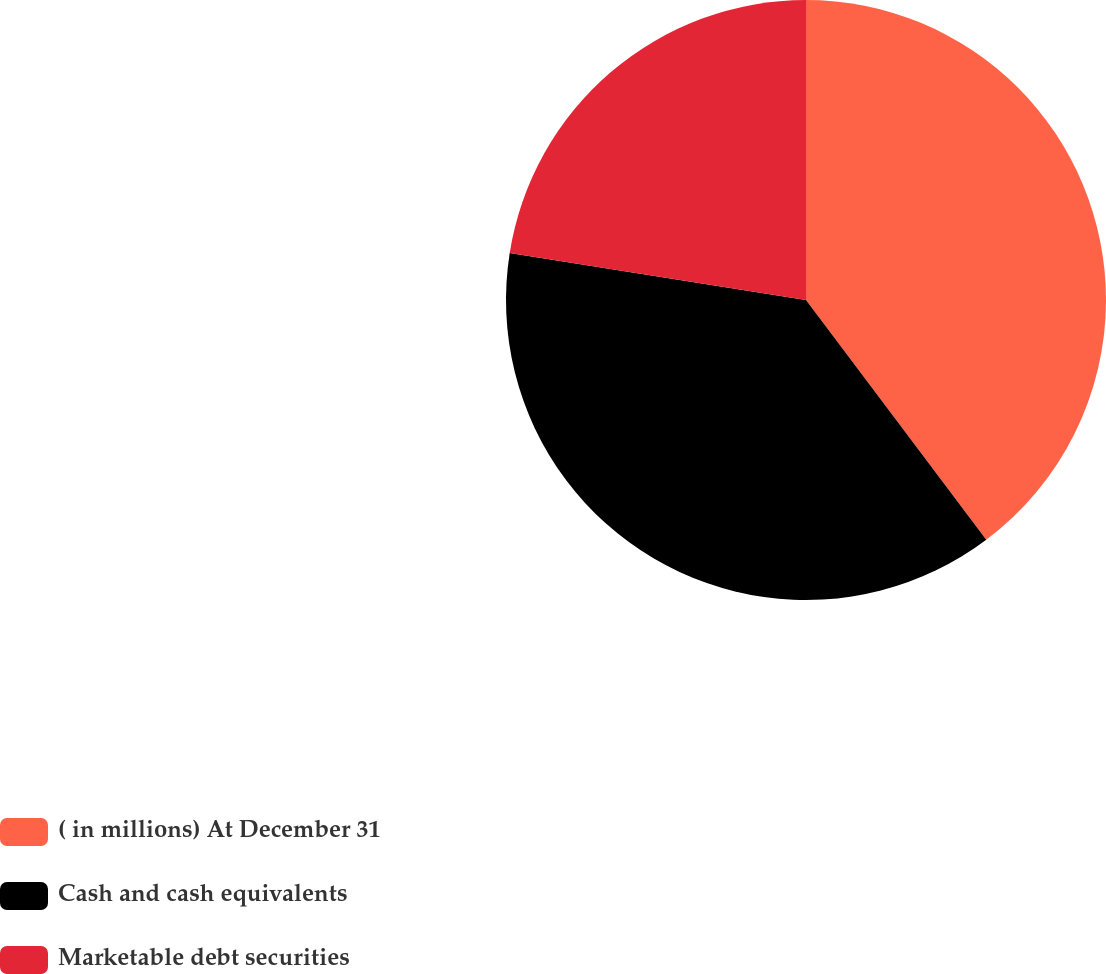Convert chart. <chart><loc_0><loc_0><loc_500><loc_500><pie_chart><fcel>( in millions) At December 31<fcel>Cash and cash equivalents<fcel>Marketable debt securities<nl><fcel>39.74%<fcel>37.77%<fcel>22.49%<nl></chart> 